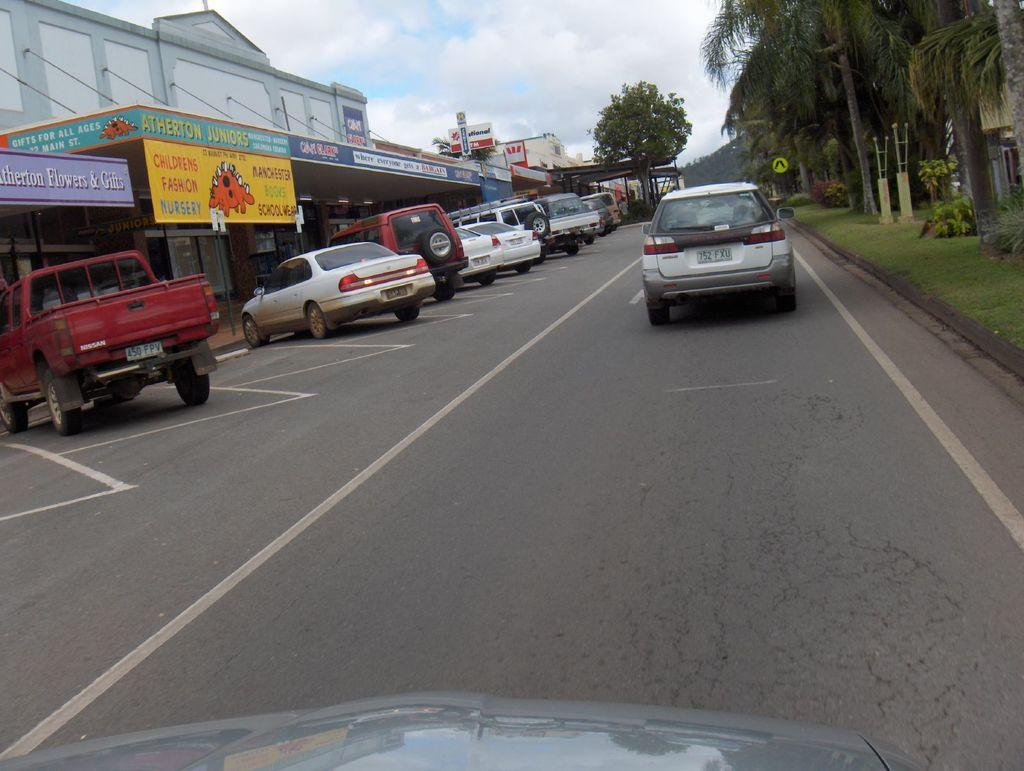What types of vehicles are present in the image? There are cars and a truck in the image. What else can be seen in the image besides vehicles? There is a banner, buildings, trees, grass, and the sky visible in the image. How many kittens are playing with the birthday curtain in the image? There are no kittens or birthday curtains present in the image. 